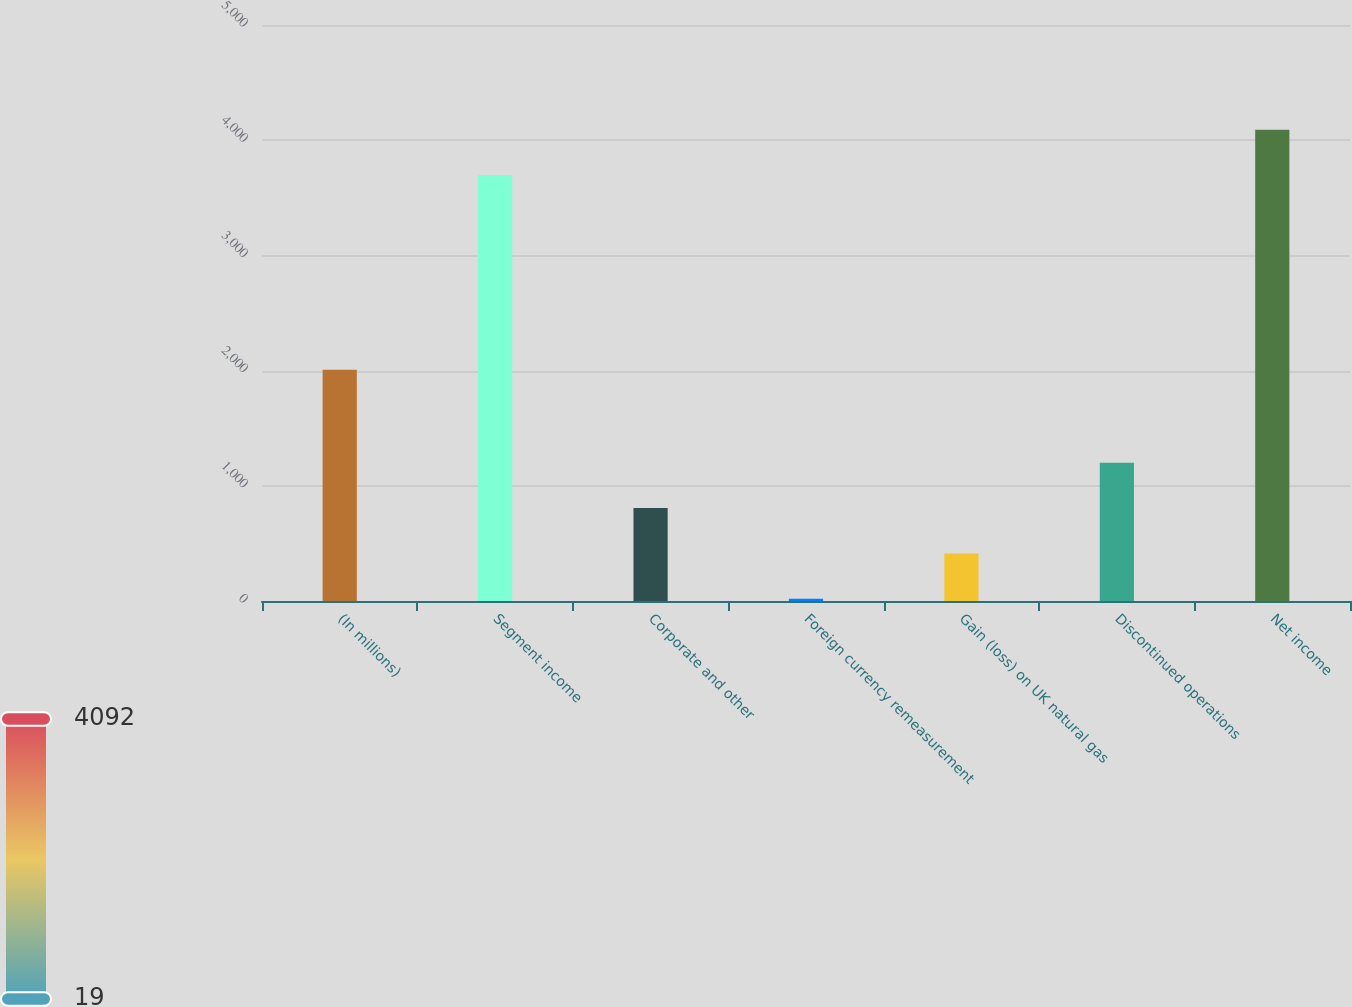<chart> <loc_0><loc_0><loc_500><loc_500><bar_chart><fcel>(In millions)<fcel>Segment income<fcel>Corporate and other<fcel>Foreign currency remeasurement<fcel>Gain (loss) on UK natural gas<fcel>Discontinued operations<fcel>Net income<nl><fcel>2007<fcel>3698<fcel>806.4<fcel>19<fcel>412.7<fcel>1200.1<fcel>4091.7<nl></chart> 